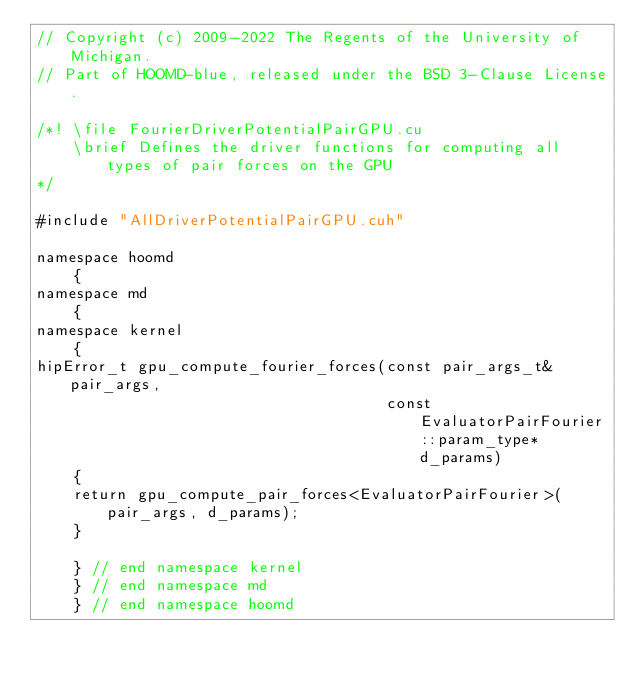Convert code to text. <code><loc_0><loc_0><loc_500><loc_500><_Cuda_>// Copyright (c) 2009-2022 The Regents of the University of Michigan.
// Part of HOOMD-blue, released under the BSD 3-Clause License.

/*! \file FourierDriverPotentialPairGPU.cu
    \brief Defines the driver functions for computing all types of pair forces on the GPU
*/

#include "AllDriverPotentialPairGPU.cuh"

namespace hoomd
    {
namespace md
    {
namespace kernel
    {
hipError_t gpu_compute_fourier_forces(const pair_args_t& pair_args,
                                      const EvaluatorPairFourier::param_type* d_params)
    {
    return gpu_compute_pair_forces<EvaluatorPairFourier>(pair_args, d_params);
    }

    } // end namespace kernel
    } // end namespace md
    } // end namespace hoomd
</code> 